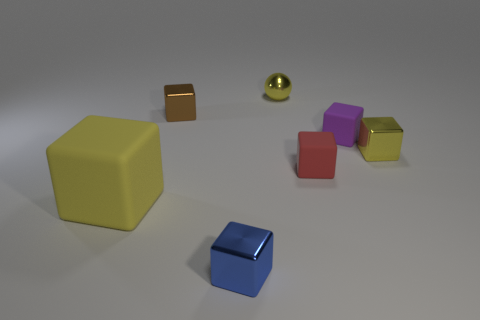Do the shiny thing to the right of the small red rubber object and the large thing have the same color?
Provide a short and direct response. Yes. How many things are either small red blocks or tiny metallic cubes behind the big yellow rubber block?
Provide a succinct answer. 3. There is a small thing that is in front of the small yellow block and behind the large yellow object; what material is it?
Provide a short and direct response. Rubber. There is a tiny yellow object that is right of the small red object; what is it made of?
Ensure brevity in your answer.  Metal. There is another small block that is the same material as the red cube; what color is it?
Offer a very short reply. Purple. Do the brown thing and the rubber thing to the left of the blue metallic thing have the same shape?
Make the answer very short. Yes. Are there any tiny matte cubes right of the small red thing?
Keep it short and to the point. Yes. There is a big thing that is the same color as the tiny metal ball; what is it made of?
Provide a short and direct response. Rubber. Is the size of the brown object the same as the shiny cube in front of the small yellow metal cube?
Your answer should be compact. Yes. Is there a large rubber object that has the same color as the metal ball?
Keep it short and to the point. Yes. 